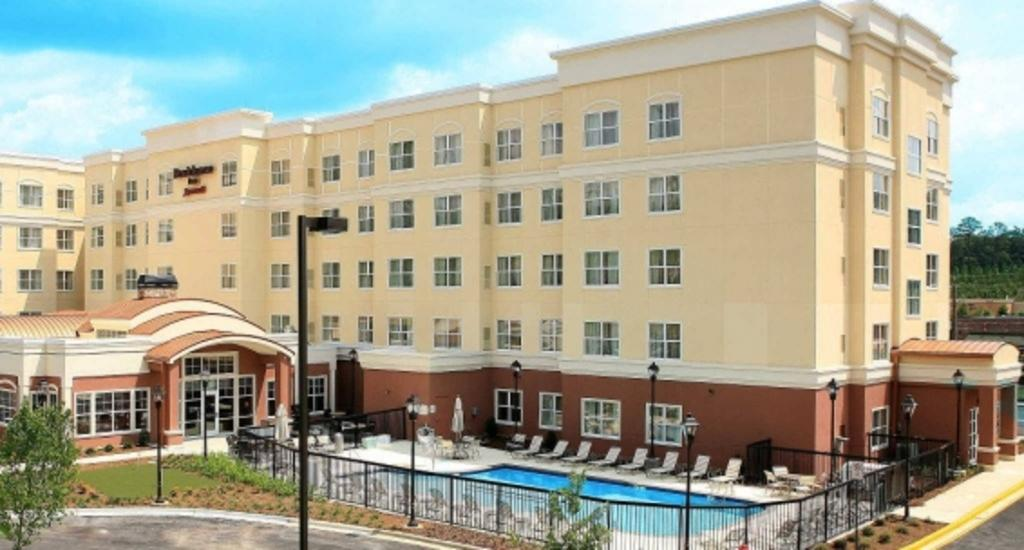What type of structure is present in the image? There is a building in the image. What feature can be seen on the building? The building has windows. What are the light sources in the image? There are light poles in the image. What type of vegetation is present in the image? There are plants and trees in the image. What type of seating is available in the image? There are chairs in the image. What is visible in the sky in the image? The sky is visible in the image. What recreational feature can be seen in the image? There is a swimming pool in the image. What type of noise can be heard coming from the jelly in the image? There is no jelly present in the image, so it is not possible to determine what noise might be heard. 